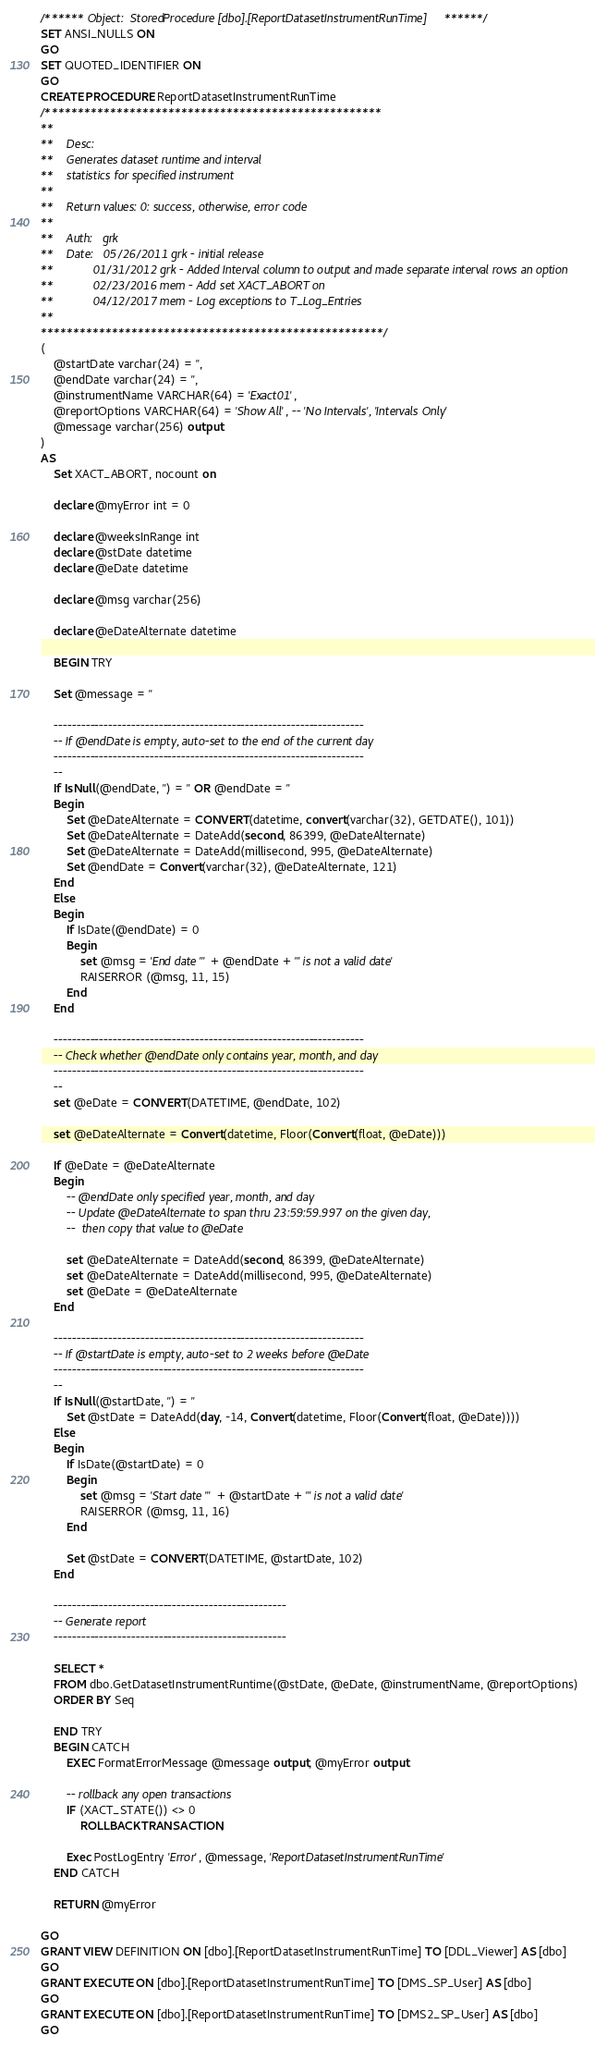Convert code to text. <code><loc_0><loc_0><loc_500><loc_500><_SQL_>/****** Object:  StoredProcedure [dbo].[ReportDatasetInstrumentRunTime] ******/
SET ANSI_NULLS ON
GO
SET QUOTED_IDENTIFIER ON
GO
CREATE PROCEDURE ReportDatasetInstrumentRunTime
/****************************************************
**
**	Desc: 
**	Generates dataset runtime and interval 
**	statistics for specified instrument
**
**	Return values: 0: success, otherwise, error code
**
**	Auth:	grk
**	Date:	05/26/2011 grk - initial release
**			01/31/2012 grk - Added Interval column to output and made separate interval rows an option
**			02/23/2016 mem - Add set XACT_ABORT on
**			04/12/2017 mem - Log exceptions to T_Log_Entries
**    
*****************************************************/
(
	@startDate varchar(24) = '',
	@endDate varchar(24) = '',
	@instrumentName VARCHAR(64) = 'Exact01',
	@reportOptions VARCHAR(64) = 'Show All', -- 'No Intervals', 'Intervals Only'
	@message varchar(256) output
)
AS
	Set XACT_ABORT, nocount on

	declare @myError int = 0
	
	declare @weeksInRange int
	declare @stDate datetime
	declare @eDate datetime

	declare @msg varchar(256)

	declare @eDateAlternate datetime

	BEGIN TRY 

	Set @message = ''
	
	--------------------------------------------------------------------
	-- If @endDate is empty, auto-set to the end of the current day
	--------------------------------------------------------------------
	--
	If IsNull(@endDate, '') = '' OR @endDate = ''
	Begin
		Set @eDateAlternate = CONVERT(datetime, convert(varchar(32), GETDATE(), 101))
		Set @eDateAlternate = DateAdd(second, 86399, @eDateAlternate)
		Set @eDateAlternate = DateAdd(millisecond, 995, @eDateAlternate)
		Set @endDate = Convert(varchar(32), @eDateAlternate, 121)
	End
	Else
	Begin
		If IsDate(@endDate) = 0
		Begin
			set @msg = 'End date "' + @endDate + '" is not a valid date'
			RAISERROR (@msg, 11, 15)
		End
	End
		
	--------------------------------------------------------------------
	-- Check whether @endDate only contains year, month, and day
	--------------------------------------------------------------------
	--
	set @eDate = CONVERT(DATETIME, @endDate, 102) 

	set @eDateAlternate = Convert(datetime, Floor(Convert(float, @eDate)))
	
	If @eDate = @eDateAlternate
	Begin
		-- @endDate only specified year, month, and day
		-- Update @eDateAlternate to span thru 23:59:59.997 on the given day,
		--  then copy that value to @eDate
		
		set @eDateAlternate = DateAdd(second, 86399, @eDateAlternate)
		set @eDateAlternate = DateAdd(millisecond, 995, @eDateAlternate)
		set @eDate = @eDateAlternate
	End
	
	--------------------------------------------------------------------
	-- If @startDate is empty, auto-set to 2 weeks before @eDate
	--------------------------------------------------------------------
	--
	If IsNull(@startDate, '') = ''
		Set @stDate = DateAdd(day, -14, Convert(datetime, Floor(Convert(float, @eDate))))
	Else
	Begin
		If IsDate(@startDate) = 0
		Begin
			set @msg = 'Start date "' + @startDate + '" is not a valid date'
			RAISERROR (@msg, 11, 16)
		End

		Set @stDate = CONVERT(DATETIME, @startDate, 102) 
	End

	---------------------------------------------------
	-- Generate report
	---------------------------------------------------

	SELECT * 
	FROM dbo.GetDatasetInstrumentRuntime(@stDate, @eDate, @instrumentName, @reportOptions)
	ORDER BY Seq

	END TRY
	BEGIN CATCH 
		EXEC FormatErrorMessage @message output, @myError output
		
		-- rollback any open transactions
		IF (XACT_STATE()) <> 0
			ROLLBACK TRANSACTION;
			
		Exec PostLogEntry 'Error', @message, 'ReportDatasetInstrumentRunTime'
	END CATCH
	
	RETURN @myError

GO
GRANT VIEW DEFINITION ON [dbo].[ReportDatasetInstrumentRunTime] TO [DDL_Viewer] AS [dbo]
GO
GRANT EXECUTE ON [dbo].[ReportDatasetInstrumentRunTime] TO [DMS_SP_User] AS [dbo]
GO
GRANT EXECUTE ON [dbo].[ReportDatasetInstrumentRunTime] TO [DMS2_SP_User] AS [dbo]
GO
</code> 